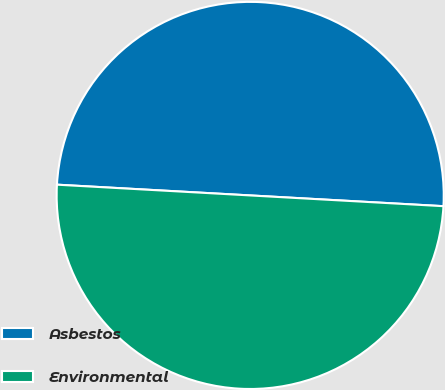Convert chart. <chart><loc_0><loc_0><loc_500><loc_500><pie_chart><fcel>Asbestos<fcel>Environmental<nl><fcel>50.0%<fcel>50.0%<nl></chart> 